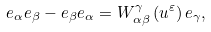<formula> <loc_0><loc_0><loc_500><loc_500>e _ { \alpha } e _ { \beta } - e _ { \beta } e _ { \alpha } = W _ { \alpha \beta } ^ { \gamma } \left ( u ^ { \varepsilon } \right ) e _ { \gamma } ,</formula> 